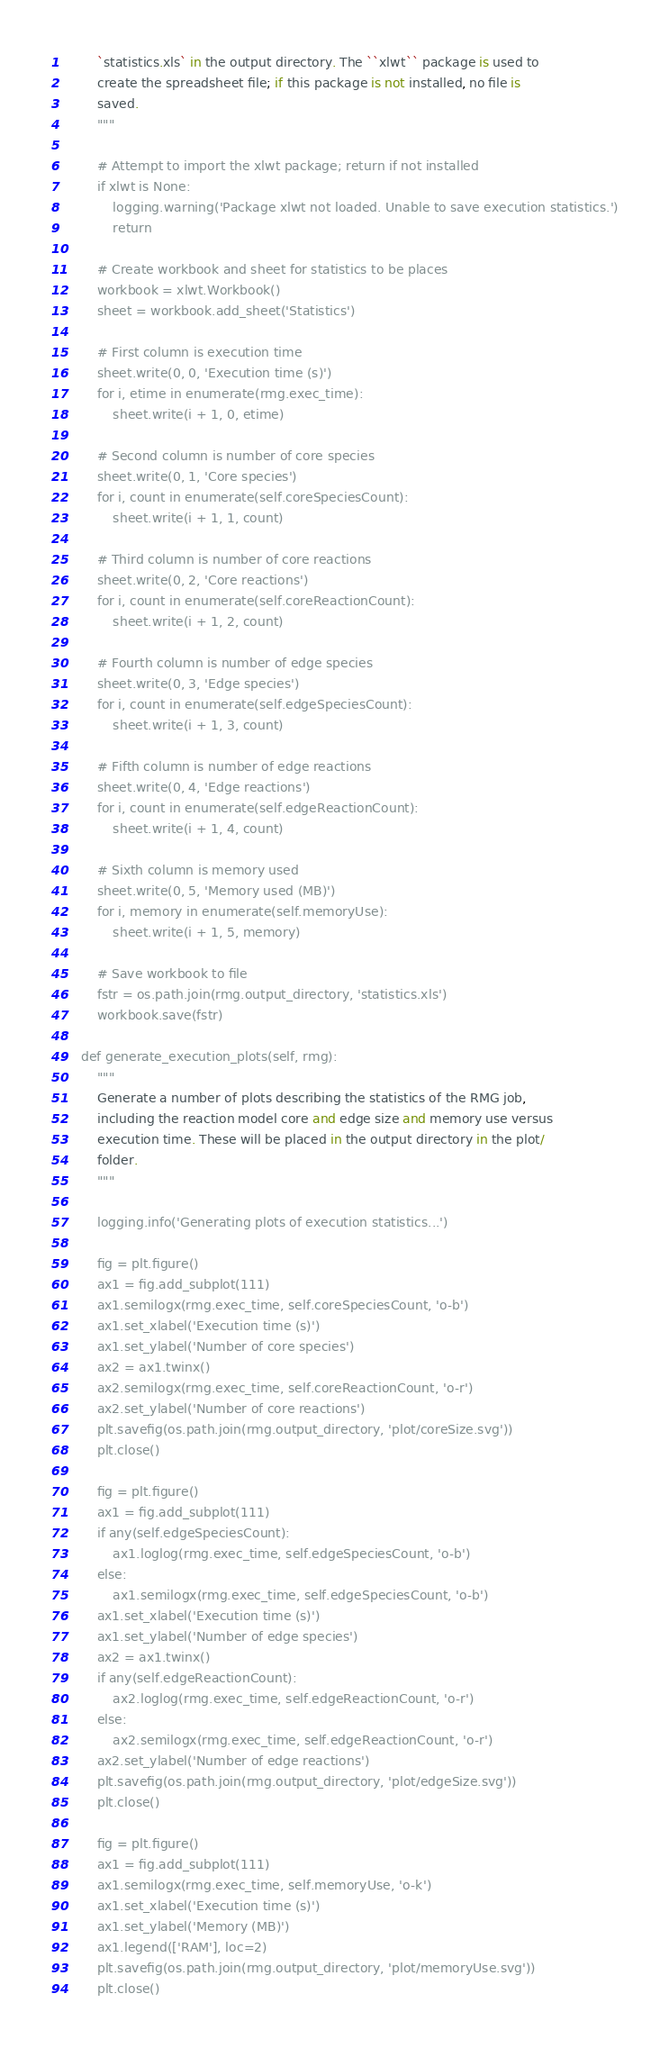Convert code to text. <code><loc_0><loc_0><loc_500><loc_500><_Python_>        `statistics.xls` in the output directory. The ``xlwt`` package is used to
        create the spreadsheet file; if this package is not installed, no file is
        saved.
        """

        # Attempt to import the xlwt package; return if not installed
        if xlwt is None:
            logging.warning('Package xlwt not loaded. Unable to save execution statistics.')
            return

        # Create workbook and sheet for statistics to be places
        workbook = xlwt.Workbook()
        sheet = workbook.add_sheet('Statistics')

        # First column is execution time
        sheet.write(0, 0, 'Execution time (s)')
        for i, etime in enumerate(rmg.exec_time):
            sheet.write(i + 1, 0, etime)

        # Second column is number of core species
        sheet.write(0, 1, 'Core species')
        for i, count in enumerate(self.coreSpeciesCount):
            sheet.write(i + 1, 1, count)

        # Third column is number of core reactions
        sheet.write(0, 2, 'Core reactions')
        for i, count in enumerate(self.coreReactionCount):
            sheet.write(i + 1, 2, count)

        # Fourth column is number of edge species
        sheet.write(0, 3, 'Edge species')
        for i, count in enumerate(self.edgeSpeciesCount):
            sheet.write(i + 1, 3, count)

        # Fifth column is number of edge reactions
        sheet.write(0, 4, 'Edge reactions')
        for i, count in enumerate(self.edgeReactionCount):
            sheet.write(i + 1, 4, count)

        # Sixth column is memory used
        sheet.write(0, 5, 'Memory used (MB)')
        for i, memory in enumerate(self.memoryUse):
            sheet.write(i + 1, 5, memory)

        # Save workbook to file
        fstr = os.path.join(rmg.output_directory, 'statistics.xls')
        workbook.save(fstr)

    def generate_execution_plots(self, rmg):
        """
        Generate a number of plots describing the statistics of the RMG job,
        including the reaction model core and edge size and memory use versus
        execution time. These will be placed in the output directory in the plot/
        folder.
        """

        logging.info('Generating plots of execution statistics...')

        fig = plt.figure()
        ax1 = fig.add_subplot(111)
        ax1.semilogx(rmg.exec_time, self.coreSpeciesCount, 'o-b')
        ax1.set_xlabel('Execution time (s)')
        ax1.set_ylabel('Number of core species')
        ax2 = ax1.twinx()
        ax2.semilogx(rmg.exec_time, self.coreReactionCount, 'o-r')
        ax2.set_ylabel('Number of core reactions')
        plt.savefig(os.path.join(rmg.output_directory, 'plot/coreSize.svg'))
        plt.close()

        fig = plt.figure()
        ax1 = fig.add_subplot(111)
        if any(self.edgeSpeciesCount):
            ax1.loglog(rmg.exec_time, self.edgeSpeciesCount, 'o-b')
        else:
            ax1.semilogx(rmg.exec_time, self.edgeSpeciesCount, 'o-b')
        ax1.set_xlabel('Execution time (s)')
        ax1.set_ylabel('Number of edge species')
        ax2 = ax1.twinx()
        if any(self.edgeReactionCount):
            ax2.loglog(rmg.exec_time, self.edgeReactionCount, 'o-r')
        else:
            ax2.semilogx(rmg.exec_time, self.edgeReactionCount, 'o-r')
        ax2.set_ylabel('Number of edge reactions')
        plt.savefig(os.path.join(rmg.output_directory, 'plot/edgeSize.svg'))
        plt.close()

        fig = plt.figure()
        ax1 = fig.add_subplot(111)
        ax1.semilogx(rmg.exec_time, self.memoryUse, 'o-k')
        ax1.set_xlabel('Execution time (s)')
        ax1.set_ylabel('Memory (MB)')
        ax1.legend(['RAM'], loc=2)
        plt.savefig(os.path.join(rmg.output_directory, 'plot/memoryUse.svg'))
        plt.close()
</code> 